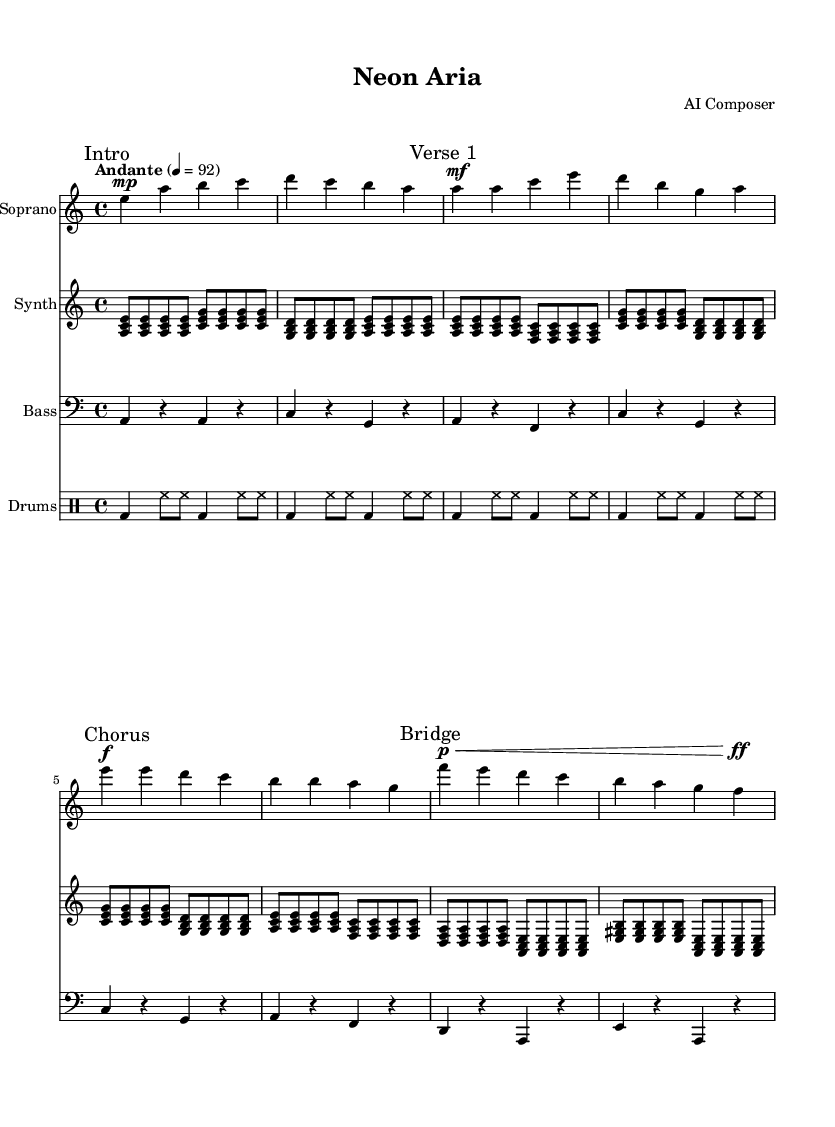What is the key signature of this music? The key signature is indicated by the sharp or flat symbols at the beginning of the staff. In this case, the music uses A minor, which has no sharps or flats.
Answer: A minor What is the time signature of this music? The time signature is placed at the beginning of the music, specifically after the key signature. This piece is written in 4/4 time, meaning there are four beats per measure.
Answer: 4/4 What is the tempo marking for this piece? The tempo marking is found at the beginning of the score, indicating the speed of the music. It states "Andante," which means moderate walking pace, with a metronome marking of 92 beats per minute.
Answer: Andante Which instrument plays the highest melodic line? By analyzing the score layout, the soprano line is situated above the other instruments, indicating it carries the highest melodic content in this composition.
Answer: Soprano How many distinct sections are present in the vocal part? The vocal part is divided into four distinct sections, marked as Intro, Verse 1, Chorus, and Bridge. Each section has its own musical phrases and characteristics.
Answer: Four What type of rhythmic pattern can be observed in the drum part? The drum part features a four-on-the-floor pattern, which is a common rhythmic structure in electronic and dance music, characterized by a bass drum hitting on every beat.
Answer: Four-on-the-floor Is there a use of electronic elements in this contemporary opera? The presence of a synthesizer part throughout the score indicates the incorporation of electronic elements, merging traditional operatic aspects with modern electronic music styles.
Answer: Yes 